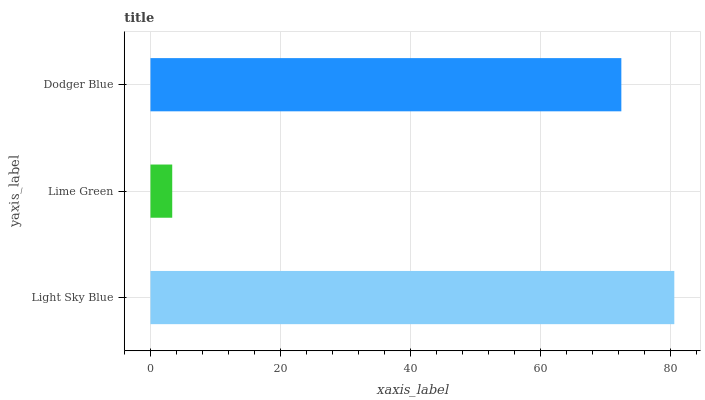Is Lime Green the minimum?
Answer yes or no. Yes. Is Light Sky Blue the maximum?
Answer yes or no. Yes. Is Dodger Blue the minimum?
Answer yes or no. No. Is Dodger Blue the maximum?
Answer yes or no. No. Is Dodger Blue greater than Lime Green?
Answer yes or no. Yes. Is Lime Green less than Dodger Blue?
Answer yes or no. Yes. Is Lime Green greater than Dodger Blue?
Answer yes or no. No. Is Dodger Blue less than Lime Green?
Answer yes or no. No. Is Dodger Blue the high median?
Answer yes or no. Yes. Is Dodger Blue the low median?
Answer yes or no. Yes. Is Light Sky Blue the high median?
Answer yes or no. No. Is Lime Green the low median?
Answer yes or no. No. 